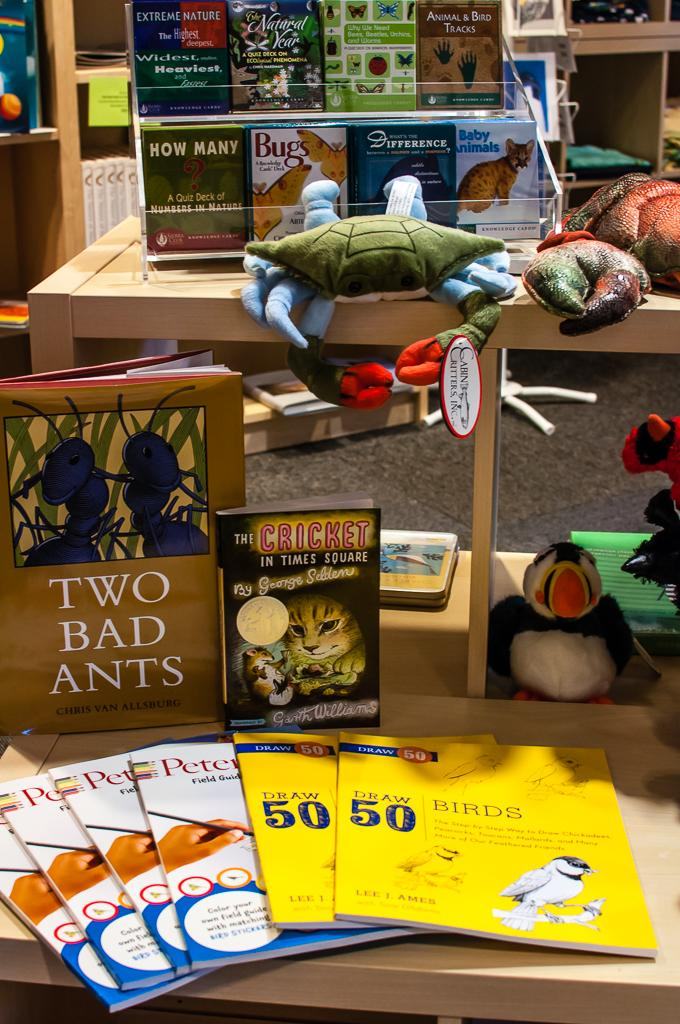<image>
Relay a brief, clear account of the picture shown. A display with a stuffed animals and books such as Two Bad Ants. 